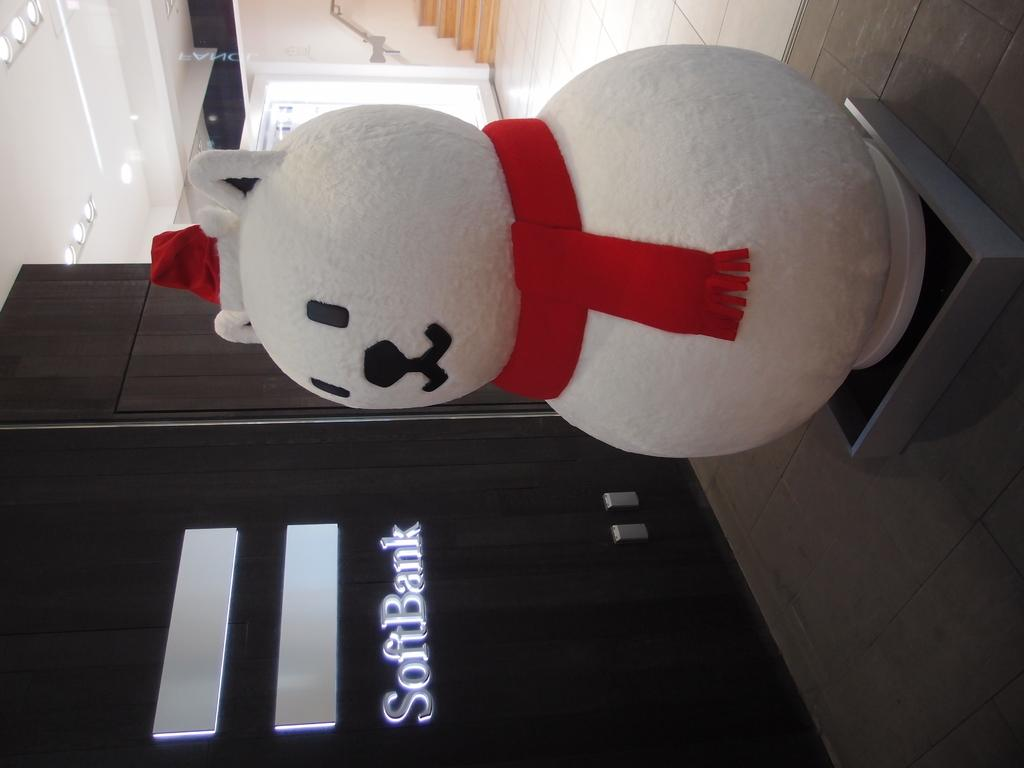What is placed on top of the box in the image? There is a doll on a box in the image. What can be seen illuminating the scene in the image? There are lights visible in the image. What architectural feature is present in the image? There are stairs in the image. What is written or drawn on a surface in the image? There is text on a wall in the image. What part of the room is visible from above in the image? The ceiling is visible in the image. What type of grape is being used to paint the text on the wall in the image? There are no grapes present in the image, and the text on the wall is not being painted with any grapes. 